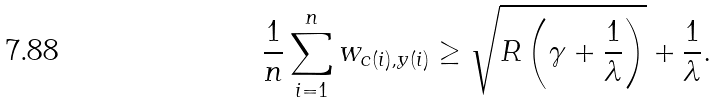Convert formula to latex. <formula><loc_0><loc_0><loc_500><loc_500>\frac { 1 } { n } \sum ^ { n } _ { i = 1 } w _ { c ( i ) , y ( i ) } \geq \sqrt { R \left ( \gamma + \frac { 1 } { \lambda } \right ) } + \frac { 1 } { \lambda } .</formula> 